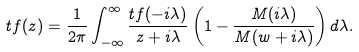<formula> <loc_0><loc_0><loc_500><loc_500>\L t f ( z ) = \frac { 1 } { 2 \pi } \int _ { - \infty } ^ { \infty } \frac { \L t f ( - i \lambda ) } { z + i \lambda } \left ( 1 - \frac { M ( i \lambda ) } { M ( w + i \lambda ) } \right ) d \lambda .</formula> 